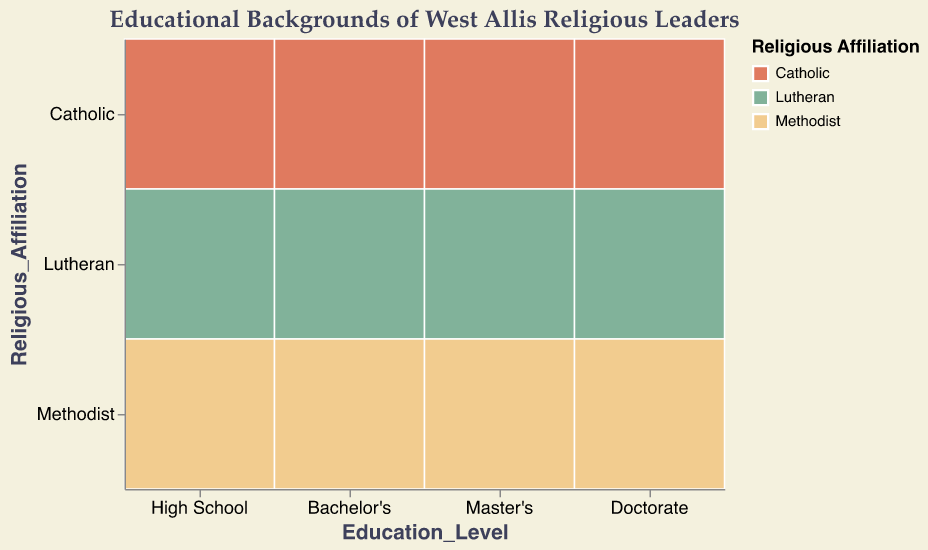What is the most common educational level among Catholic religious leaders? Count the number of entries for each educational level under the Catholic affiliation. The counts are 8 (High School), 12 (Bachelor's), 15 (Master's), and 5 (Doctorate). The highest count is 15 under Master's.
Answer: Master's Which religious affiliation has the highest number of Doctorate degree holders? Compare the counts of Doctorate degree holders across Catholic, Lutheran, and Methodist affiliations. The counts are 5 (Catholic), 3 (Lutheran), and 2 (Methodist). The highest count is 5 for Catholics.
Answer: Catholic How many Catholic religious leaders have at least a Bachelor's degree? Sum the counts for Bachelor's, Master's, and Doctorate degrees under the Catholic affiliation. The counts are 12 (Bachelor's), 15 (Master's), and 5 (Doctorate). The total is 12 + 15 + 5 = 32.
Answer: 32 Which educational level shows the least overall number of religious leaders across all affiliations? Sum the counts for each educational level across all affiliations. High School: 8+6+4=18, Bachelor's: 12+10+7=29, Master's: 15+11+9=35, Doctorate: 5+3+2=10. The least count is 10 for Doctorate.
Answer: Doctorate Compare the number of Lutheran religious leaders with a Master's degree to the number of Methodist leaders with the same degree. The counts for Lutheran and Methodist religious leaders with a Master's degree are 11 and 9, respectively.
Answer: Lutheran religious leaders have a higher count What percentage of High School educated religious leaders are Methodist? Calculate the total number of High School educated religious leaders: 8 (Catholic) + 6 (Lutheran) + 4 (Methodist) = 18. The percentage for Methodist is (4 / 18) * 100 = 22.22%.
Answer: 22.22% Which group has a higher overall number of Bachelor's degree holders, Catholics or Lutherans? Compare the counts of Bachelor's degree holders between Catholics and Lutherans. The counts are 12 (Catholic) and 10 (Lutheran). Catholics have a higher number.
Answer: Catholics How does the distribution of educational levels among Methodist religious leaders compare to that of Lutheran leaders? For Methodists: High School (4), Bachelor's (7), Master's (9), Doctorate (2). For Lutherans: High School (6), Bachelor's (10), Master's (11), Doctorate (3). Methodists have smaller counts in each educational level compared to Lutherans.
Answer: Lutheran leaders have higher counts at each educational level What is the most common combination of educational level and religious affiliation? Look for the highest count across all combinations. The Master's degree for Catholics has the highest count of 15.
Answer: Master's degree for Catholics 